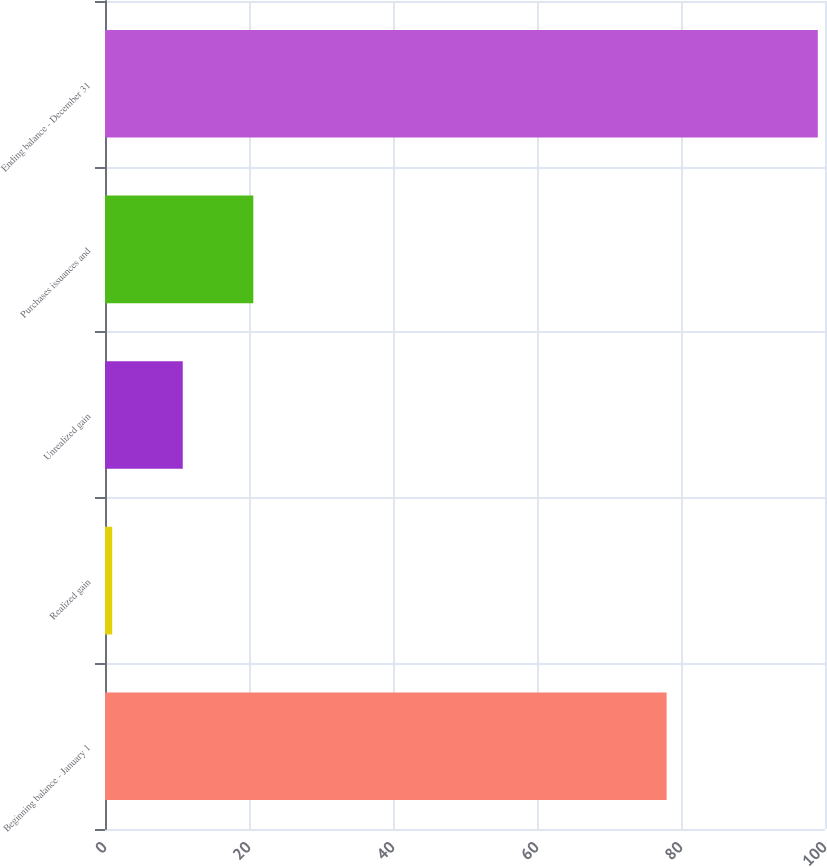Convert chart. <chart><loc_0><loc_0><loc_500><loc_500><bar_chart><fcel>Beginning balance - January 1<fcel>Realized gain<fcel>Unrealized gain<fcel>Purchases issuances and<fcel>Ending balance - December 31<nl><fcel>78<fcel>1<fcel>10.8<fcel>20.6<fcel>99<nl></chart> 